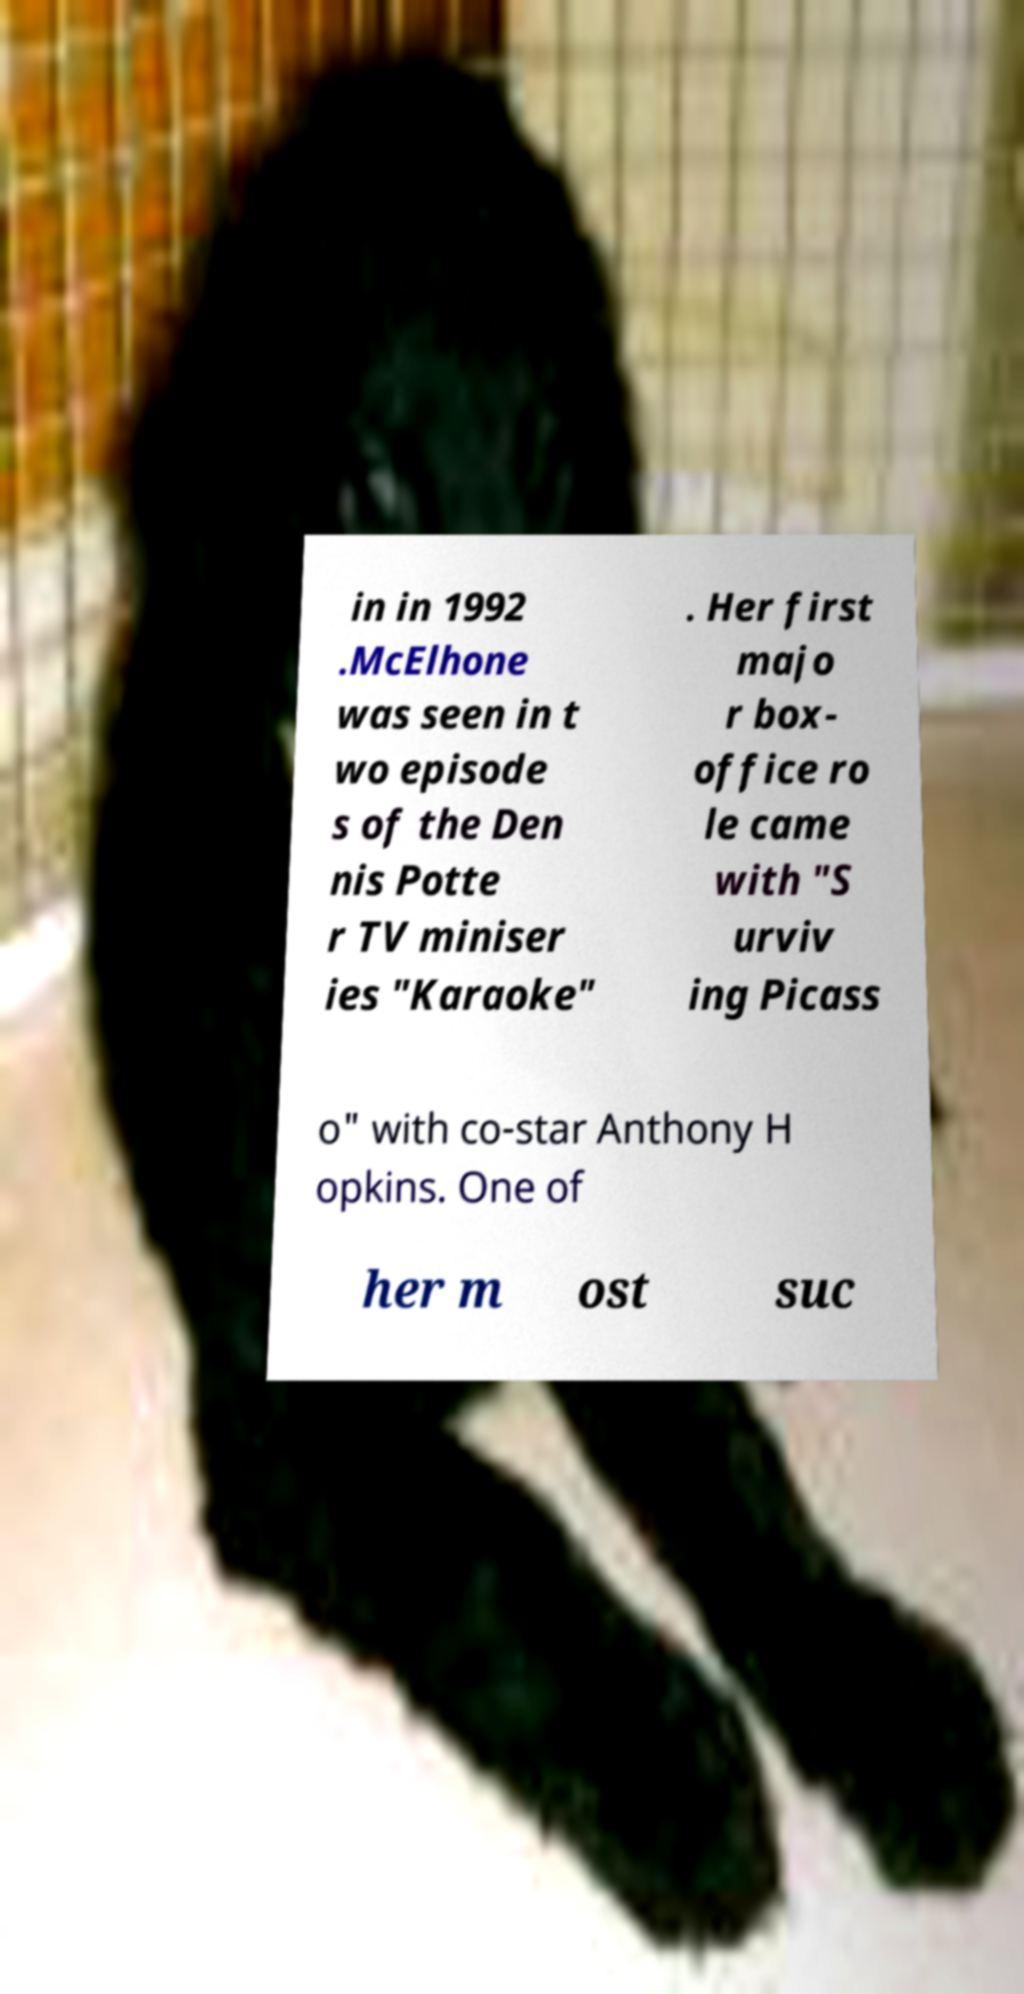There's text embedded in this image that I need extracted. Can you transcribe it verbatim? in in 1992 .McElhone was seen in t wo episode s of the Den nis Potte r TV miniser ies "Karaoke" . Her first majo r box- office ro le came with "S urviv ing Picass o" with co-star Anthony H opkins. One of her m ost suc 